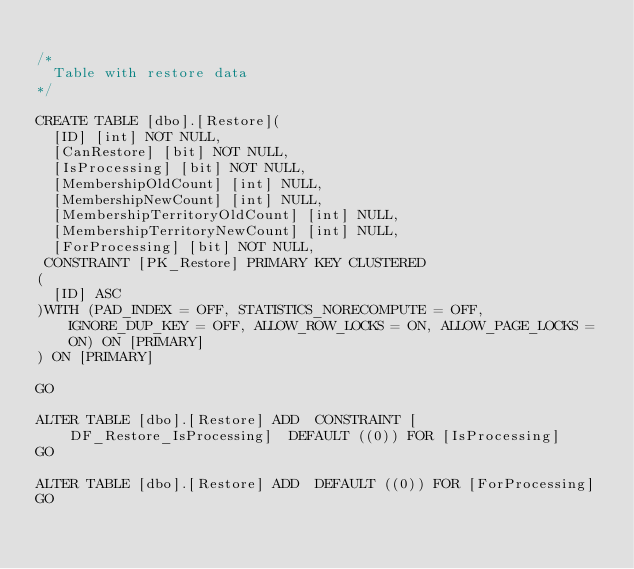<code> <loc_0><loc_0><loc_500><loc_500><_SQL_>
/*
	Table with restore data
*/

CREATE TABLE [dbo].[Restore](
	[ID] [int] NOT NULL,
	[CanRestore] [bit] NOT NULL,
	[IsProcessing] [bit] NOT NULL,
	[MembershipOldCount] [int] NULL,
	[MembershipNewCount] [int] NULL,
	[MembershipTerritoryOldCount] [int] NULL,
	[MembershipTerritoryNewCount] [int] NULL,
	[ForProcessing] [bit] NOT NULL,
 CONSTRAINT [PK_Restore] PRIMARY KEY CLUSTERED 
(
	[ID] ASC
)WITH (PAD_INDEX = OFF, STATISTICS_NORECOMPUTE = OFF, IGNORE_DUP_KEY = OFF, ALLOW_ROW_LOCKS = ON, ALLOW_PAGE_LOCKS = ON) ON [PRIMARY]
) ON [PRIMARY]

GO

ALTER TABLE [dbo].[Restore] ADD  CONSTRAINT [DF_Restore_IsProcessing]  DEFAULT ((0)) FOR [IsProcessing]
GO

ALTER TABLE [dbo].[Restore] ADD  DEFAULT ((0)) FOR [ForProcessing]
GO



</code> 